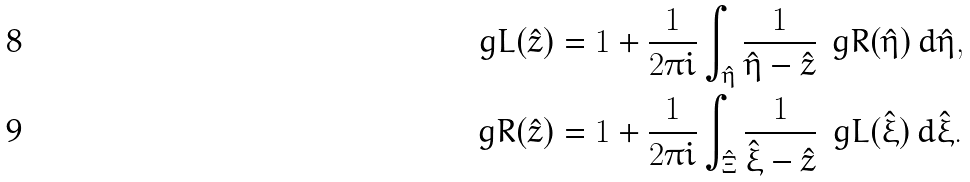<formula> <loc_0><loc_0><loc_500><loc_500>\ g L ( \hat { z } ) & = 1 + \frac { 1 } { 2 \pi i } \int _ { \hat { \eta } } \frac { 1 } { \hat { \eta } - \hat { z } } \, \ g R ( \hat { \eta } ) \, d \hat { \eta } , \\ \ g R ( \hat { z } ) & = 1 + \frac { 1 } { 2 \pi i } \int _ { \hat { \Xi } } \frac { 1 } { \hat { \xi } - \hat { z } } \, \ g L ( \hat { \xi } ) \, d \hat { \xi } .</formula> 